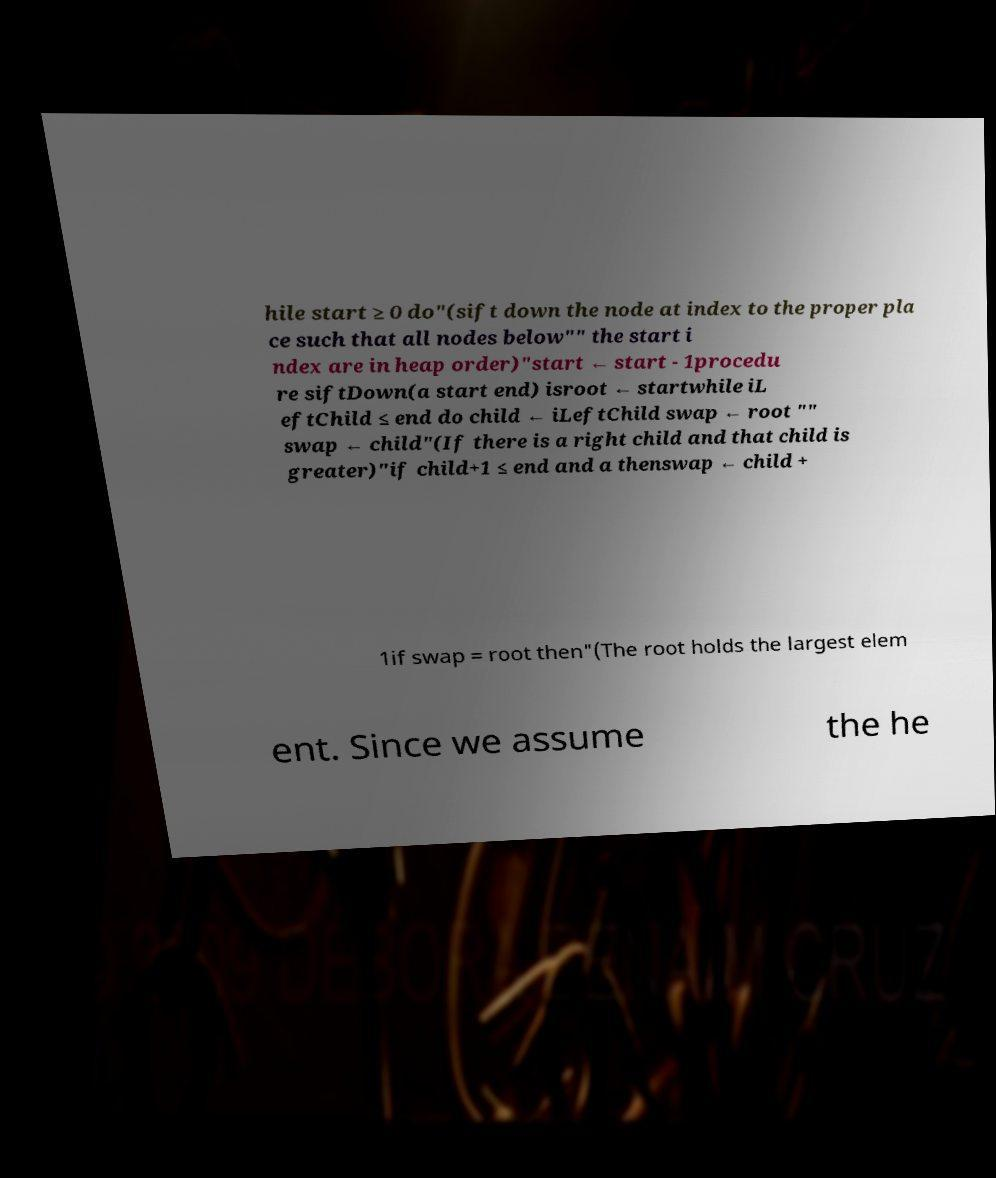Can you accurately transcribe the text from the provided image for me? hile start ≥ 0 do"(sift down the node at index to the proper pla ce such that all nodes below"" the start i ndex are in heap order)"start ← start - 1procedu re siftDown(a start end) isroot ← startwhile iL eftChild ≤ end do child ← iLeftChild swap ← root "" swap ← child"(If there is a right child and that child is greater)"if child+1 ≤ end and a thenswap ← child + 1if swap = root then"(The root holds the largest elem ent. Since we assume the he 